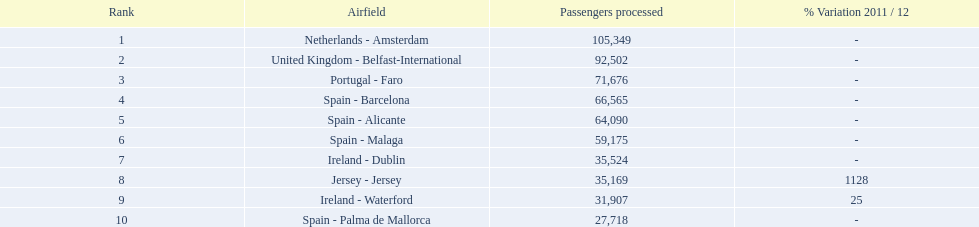What is the best rank? 1. What is the airport? Netherlands - Amsterdam. 